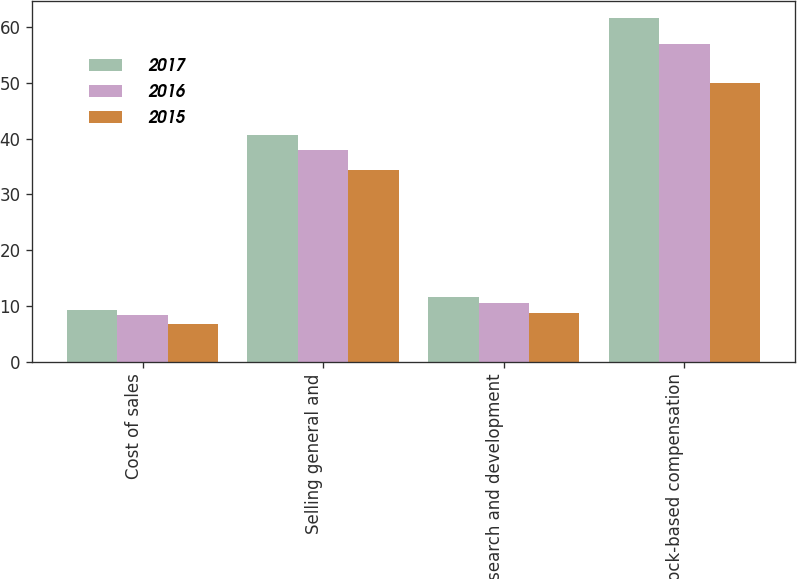Convert chart. <chart><loc_0><loc_0><loc_500><loc_500><stacked_bar_chart><ecel><fcel>Cost of sales<fcel>Selling general and<fcel>Research and development<fcel>Total stock-based compensation<nl><fcel>2017<fcel>9.2<fcel>40.7<fcel>11.7<fcel>61.6<nl><fcel>2016<fcel>8.4<fcel>38<fcel>10.5<fcel>56.9<nl><fcel>2015<fcel>6.8<fcel>34.3<fcel>8.8<fcel>49.9<nl></chart> 